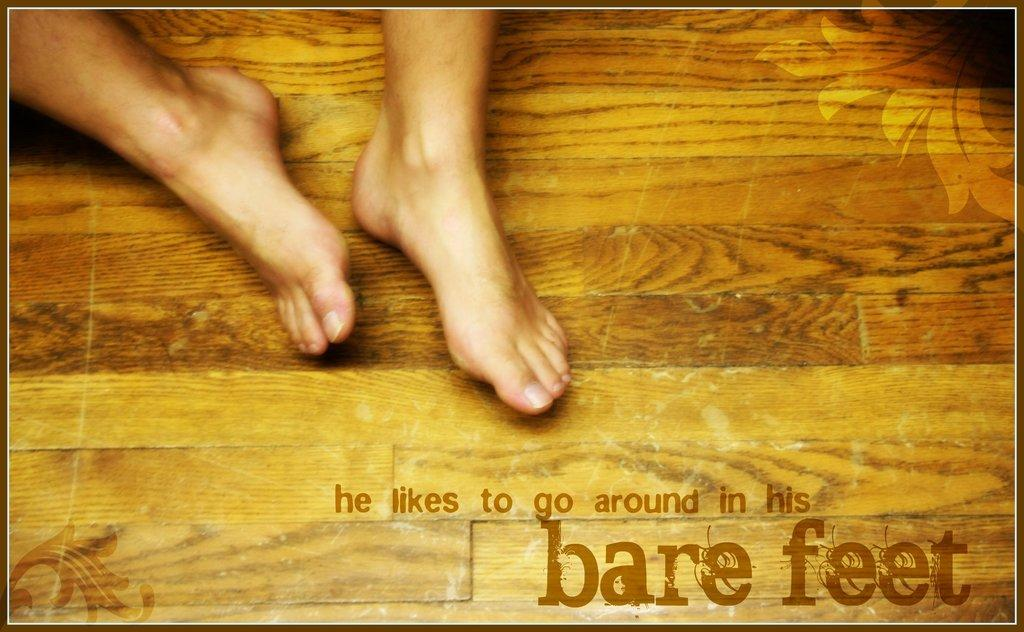<image>
Present a compact description of the photo's key features. Bare feet can be seen on a wood floor, with a statement that he likes to go around with bare feet. 